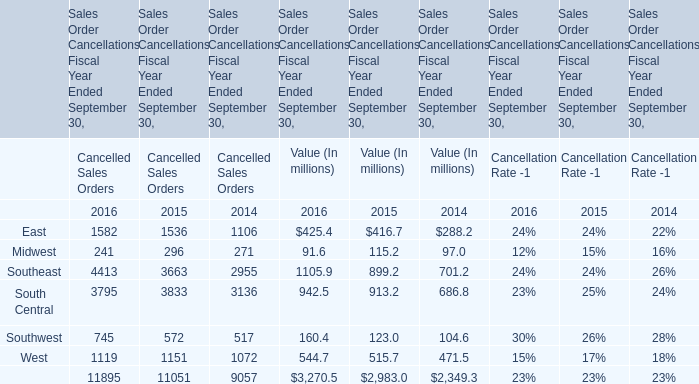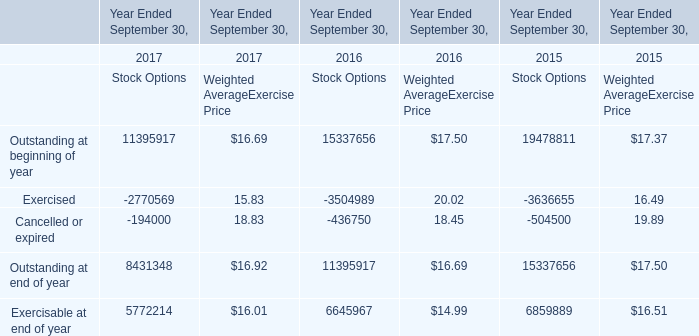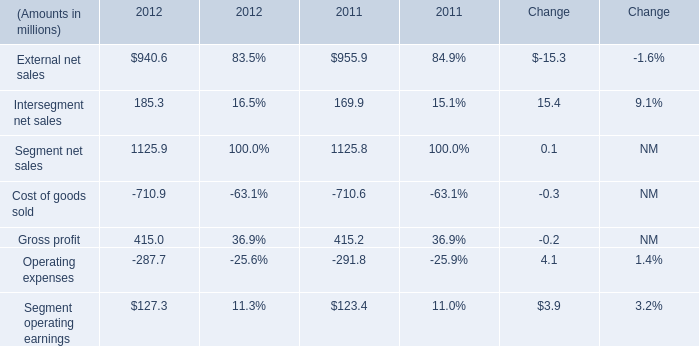What is the difference between 2016 and 2015 's highest Value of Sales Order Cancellations Fiscal Year Ended September 30? (in million) 
Computations: (3270.5 - 2983.0)
Answer: 287.5. 